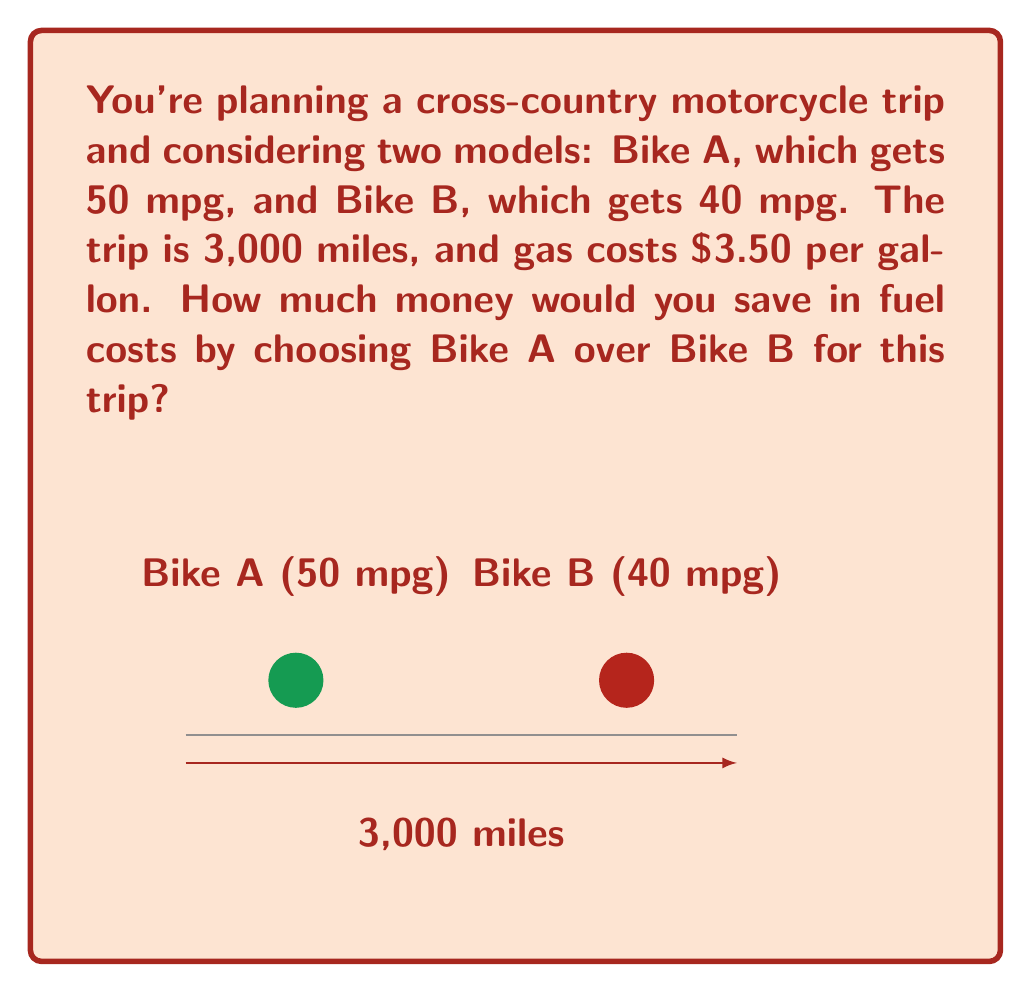Solve this math problem. Let's approach this step-by-step:

1) First, calculate the amount of fuel each bike would use for the trip:

   For Bike A: $\text{Fuel used}_A = \frac{\text{Distance}}{\text{Fuel efficiency}_A} = \frac{3000 \text{ miles}}{50 \text{ mpg}} = 60 \text{ gallons}$

   For Bike B: $\text{Fuel used}_B = \frac{\text{Distance}}{\text{Fuel efficiency}_B} = \frac{3000 \text{ miles}}{40 \text{ mpg}} = 75 \text{ gallons}$

2) Now, calculate the fuel cost for each bike:

   Bike A: $\text{Cost}_A = \text{Fuel used}_A \times \text{Price per gallon} = 60 \text{ gallons} \times \$3.50 = \$210$

   Bike B: $\text{Cost}_B = \text{Fuel used}_B \times \text{Price per gallon} = 75 \text{ gallons} \times \$3.50 = \$262.50$

3) To find the savings, subtract the cost of Bike A from the cost of Bike B:

   $\text{Savings} = \text{Cost}_B - \text{Cost}_A = \$262.50 - \$210 = \$52.50$

Therefore, by choosing Bike A, you would save $52.50 on fuel costs for this trip.
Answer: $52.50 